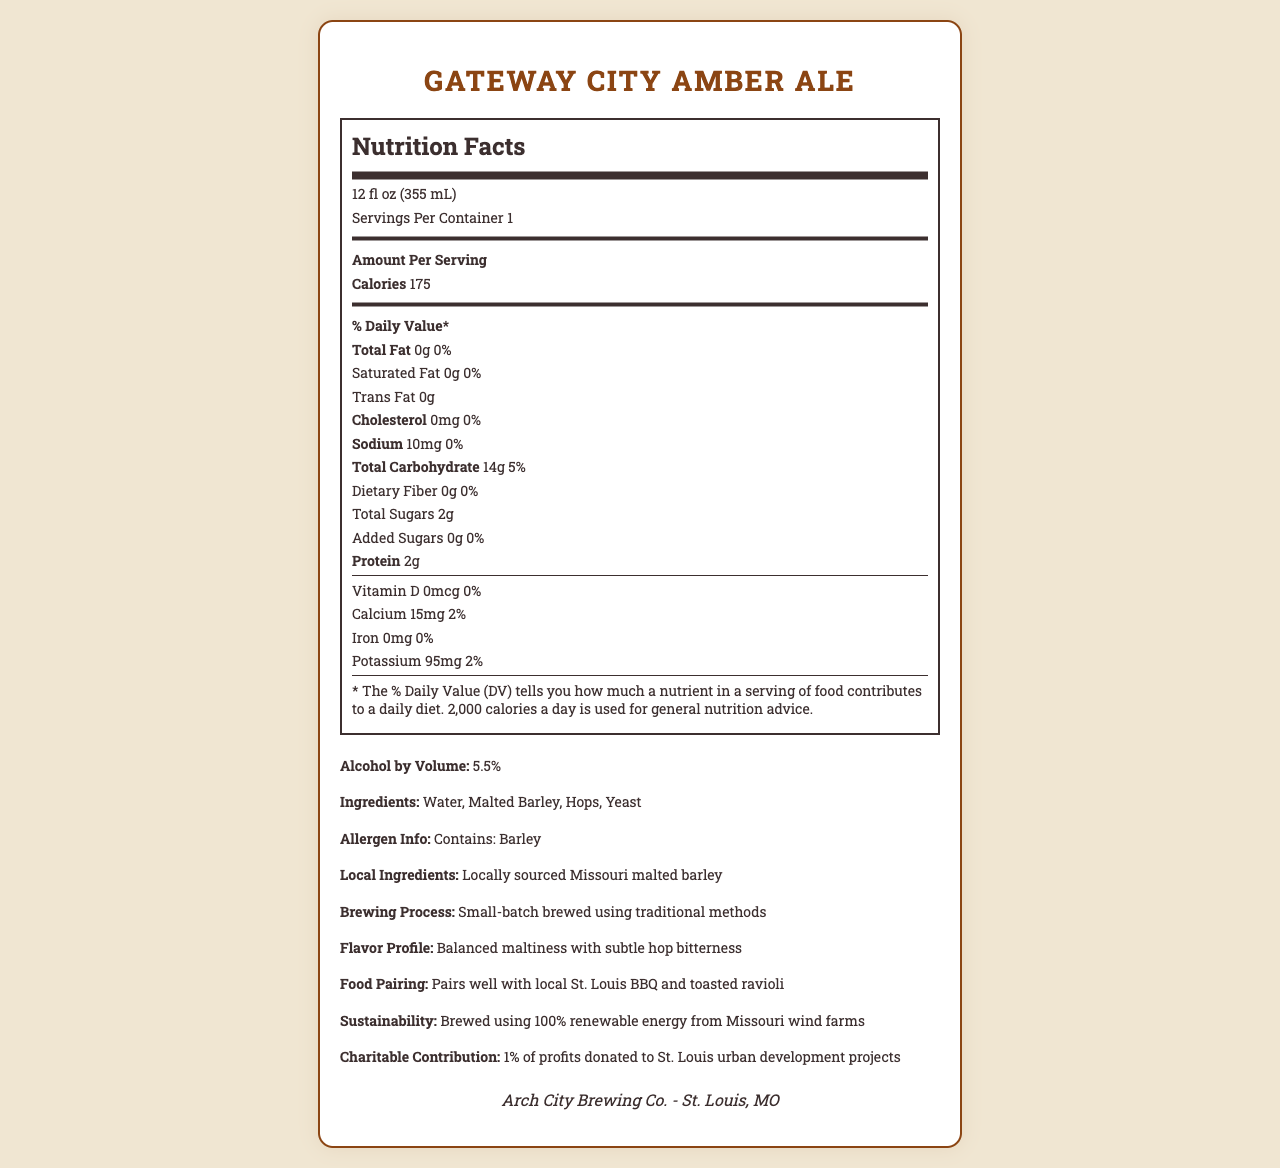What is the serving size of Gateway City Amber Ale? The serving size is clearly stated in the Nutrition Facts Label under "Servings Per Container."
Answer: 12 fl oz (355 mL) What is the total carbohydrate content per serving? The Nutrition Facts Label lists "Total Carbohydrate" content as 14 grams per serving.
Answer: 14g How many calories are in a single serving of this craft beer? The Nutrition Facts Label contains the specific calorie amount per serving, which is listed as 175 calories.
Answer: 175 calories What is the amount of protein in the Gateway City Amber Ale? The label explicitly lists the protein content as 2 grams per serving.
Answer: 2g How much sodium does a single serving contain? The Nutrition Facts Label states that the sodium content is 10 milligrams per serving.
Answer: 10mg Does the Gateway City Amber Ale contain any saturated fat? The Nutrition Facts Label shows that the saturated fat content is 0 grams, which means it contains no saturated fat.
Answer: No Which of the following best describes the brewing process used for this beer? A. Mass-produced using automated processes B. Small-batch brewed using traditional methods C. Imported from another country The additional information section states that the beer is "Small-batch brewed using traditional methods."
Answer: B. Small-batch brewed using traditional methods Where is the Arch City Brewing Co. located? A. New York, NY B. Los Angeles, CA C. St. Louis, MO D. Chicago, IL The brewery location is listed as St. Louis, MO in the brewery-info section at the bottom of the document.
Answer: C. St. Louis, MO Does Gateway City Amber Ale pair well with local St. Louis BBQ and toasted ravioli? The additional information section lists food pairings and suggests it pairs well with local St. Louis BBQ and toasted ravioli.
Answer: Yes Is there any information about whether this craft beer contains gluten? The provided document does not mention gluten content or gluten-free status.
Answer: Not enough information Summarize the main features of the Gateway City Amber Ale as presented in the document. The main features of the document include the nutritional content, flavor profile, brewing process, and community contributions of the Gateway City Amber Ale. These details help understand its nutritional value, taste, and the brewery's commitment to sustainability and local development.
Answer: Gateway City Amber Ale by Arch City Brewing Co. in St. Louis, MO, is a craft beer with 175 calories, 14g total carbohydrates, and 2g protein per 12 fl oz serving. It contains no fats or cholesterol and is low in sodium. The beer is small-batch brewed using traditional methods and features a balanced maltiness with subtle hop bitterness. It pairs well with local St. Louis BBQ and toasted ravioli. The brewery uses locally sourced Missouri malted barley and renewable energy from Missouri wind farms. Additionally, 1% of the profits are donated to St. Louis urban development projects. 